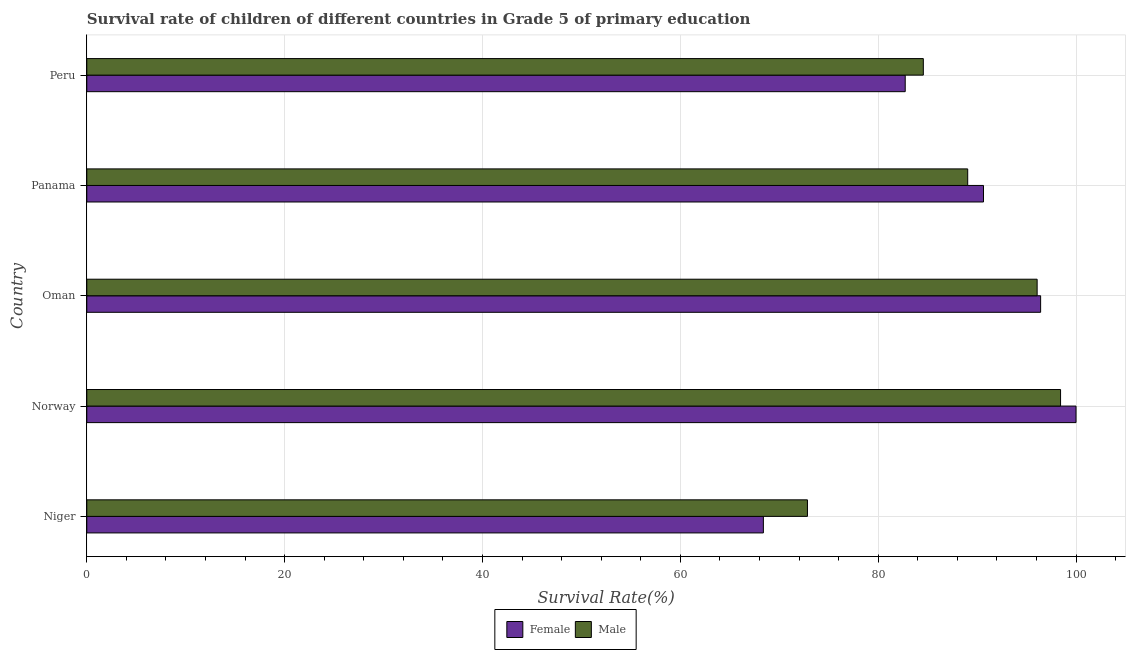How many different coloured bars are there?
Provide a succinct answer. 2. Are the number of bars on each tick of the Y-axis equal?
Offer a terse response. Yes. How many bars are there on the 4th tick from the bottom?
Offer a terse response. 2. What is the label of the 5th group of bars from the top?
Provide a short and direct response. Niger. What is the survival rate of female students in primary education in Oman?
Provide a short and direct response. 96.42. Across all countries, what is the maximum survival rate of male students in primary education?
Give a very brief answer. 98.44. Across all countries, what is the minimum survival rate of male students in primary education?
Offer a very short reply. 72.85. In which country was the survival rate of male students in primary education maximum?
Your answer should be compact. Norway. In which country was the survival rate of male students in primary education minimum?
Provide a succinct answer. Niger. What is the total survival rate of male students in primary education in the graph?
Offer a terse response. 440.97. What is the difference between the survival rate of female students in primary education in Niger and that in Peru?
Provide a short and direct response. -14.34. What is the difference between the survival rate of female students in primary education in Panama and the survival rate of male students in primary education in Peru?
Offer a terse response. 6.08. What is the average survival rate of female students in primary education per country?
Provide a short and direct response. 87.64. What is the difference between the survival rate of female students in primary education and survival rate of male students in primary education in Oman?
Provide a succinct answer. 0.35. In how many countries, is the survival rate of male students in primary education greater than 68 %?
Give a very brief answer. 5. What is the ratio of the survival rate of male students in primary education in Panama to that in Peru?
Keep it short and to the point. 1.05. Is the survival rate of female students in primary education in Norway less than that in Peru?
Your response must be concise. No. Is the difference between the survival rate of male students in primary education in Niger and Panama greater than the difference between the survival rate of female students in primary education in Niger and Panama?
Your answer should be compact. Yes. What is the difference between the highest and the second highest survival rate of male students in primary education?
Provide a succinct answer. 2.37. What is the difference between the highest and the lowest survival rate of male students in primary education?
Provide a short and direct response. 25.59. In how many countries, is the survival rate of male students in primary education greater than the average survival rate of male students in primary education taken over all countries?
Your answer should be compact. 3. Are all the bars in the graph horizontal?
Make the answer very short. Yes. How many countries are there in the graph?
Give a very brief answer. 5. Does the graph contain any zero values?
Provide a short and direct response. No. Does the graph contain grids?
Offer a very short reply. Yes. How many legend labels are there?
Your answer should be very brief. 2. How are the legend labels stacked?
Offer a very short reply. Horizontal. What is the title of the graph?
Keep it short and to the point. Survival rate of children of different countries in Grade 5 of primary education. Does "National Visitors" appear as one of the legend labels in the graph?
Give a very brief answer. No. What is the label or title of the X-axis?
Offer a terse response. Survival Rate(%). What is the Survival Rate(%) of Female in Niger?
Provide a short and direct response. 68.39. What is the Survival Rate(%) of Male in Niger?
Your answer should be very brief. 72.85. What is the Survival Rate(%) of Female in Norway?
Give a very brief answer. 100. What is the Survival Rate(%) in Male in Norway?
Provide a succinct answer. 98.44. What is the Survival Rate(%) of Female in Oman?
Ensure brevity in your answer.  96.42. What is the Survival Rate(%) in Male in Oman?
Ensure brevity in your answer.  96.07. What is the Survival Rate(%) in Female in Panama?
Offer a terse response. 90.65. What is the Survival Rate(%) of Male in Panama?
Give a very brief answer. 89.05. What is the Survival Rate(%) of Female in Peru?
Provide a short and direct response. 82.73. What is the Survival Rate(%) of Male in Peru?
Provide a short and direct response. 84.56. Across all countries, what is the maximum Survival Rate(%) in Male?
Your answer should be compact. 98.44. Across all countries, what is the minimum Survival Rate(%) of Female?
Your answer should be very brief. 68.39. Across all countries, what is the minimum Survival Rate(%) of Male?
Your answer should be compact. 72.85. What is the total Survival Rate(%) in Female in the graph?
Make the answer very short. 438.2. What is the total Survival Rate(%) in Male in the graph?
Offer a very short reply. 440.97. What is the difference between the Survival Rate(%) in Female in Niger and that in Norway?
Give a very brief answer. -31.61. What is the difference between the Survival Rate(%) of Male in Niger and that in Norway?
Offer a terse response. -25.59. What is the difference between the Survival Rate(%) in Female in Niger and that in Oman?
Give a very brief answer. -28.03. What is the difference between the Survival Rate(%) in Male in Niger and that in Oman?
Give a very brief answer. -23.22. What is the difference between the Survival Rate(%) in Female in Niger and that in Panama?
Keep it short and to the point. -22.25. What is the difference between the Survival Rate(%) of Male in Niger and that in Panama?
Your answer should be very brief. -16.2. What is the difference between the Survival Rate(%) of Female in Niger and that in Peru?
Keep it short and to the point. -14.34. What is the difference between the Survival Rate(%) of Male in Niger and that in Peru?
Your answer should be very brief. -11.71. What is the difference between the Survival Rate(%) in Female in Norway and that in Oman?
Keep it short and to the point. 3.58. What is the difference between the Survival Rate(%) in Male in Norway and that in Oman?
Ensure brevity in your answer.  2.37. What is the difference between the Survival Rate(%) in Female in Norway and that in Panama?
Offer a very short reply. 9.35. What is the difference between the Survival Rate(%) of Male in Norway and that in Panama?
Give a very brief answer. 9.39. What is the difference between the Survival Rate(%) of Female in Norway and that in Peru?
Provide a short and direct response. 17.27. What is the difference between the Survival Rate(%) of Male in Norway and that in Peru?
Give a very brief answer. 13.87. What is the difference between the Survival Rate(%) in Female in Oman and that in Panama?
Give a very brief answer. 5.78. What is the difference between the Survival Rate(%) in Male in Oman and that in Panama?
Your response must be concise. 7.02. What is the difference between the Survival Rate(%) in Female in Oman and that in Peru?
Give a very brief answer. 13.69. What is the difference between the Survival Rate(%) of Male in Oman and that in Peru?
Offer a terse response. 11.5. What is the difference between the Survival Rate(%) of Female in Panama and that in Peru?
Your answer should be very brief. 7.91. What is the difference between the Survival Rate(%) in Male in Panama and that in Peru?
Give a very brief answer. 4.49. What is the difference between the Survival Rate(%) of Female in Niger and the Survival Rate(%) of Male in Norway?
Offer a terse response. -30.04. What is the difference between the Survival Rate(%) in Female in Niger and the Survival Rate(%) in Male in Oman?
Your answer should be compact. -27.67. What is the difference between the Survival Rate(%) in Female in Niger and the Survival Rate(%) in Male in Panama?
Offer a very short reply. -20.66. What is the difference between the Survival Rate(%) in Female in Niger and the Survival Rate(%) in Male in Peru?
Offer a terse response. -16.17. What is the difference between the Survival Rate(%) of Female in Norway and the Survival Rate(%) of Male in Oman?
Your response must be concise. 3.93. What is the difference between the Survival Rate(%) of Female in Norway and the Survival Rate(%) of Male in Panama?
Your answer should be compact. 10.95. What is the difference between the Survival Rate(%) in Female in Norway and the Survival Rate(%) in Male in Peru?
Your response must be concise. 15.44. What is the difference between the Survival Rate(%) of Female in Oman and the Survival Rate(%) of Male in Panama?
Provide a short and direct response. 7.37. What is the difference between the Survival Rate(%) of Female in Oman and the Survival Rate(%) of Male in Peru?
Your answer should be very brief. 11.86. What is the difference between the Survival Rate(%) of Female in Panama and the Survival Rate(%) of Male in Peru?
Provide a succinct answer. 6.08. What is the average Survival Rate(%) in Female per country?
Your answer should be very brief. 87.64. What is the average Survival Rate(%) in Male per country?
Provide a short and direct response. 88.19. What is the difference between the Survival Rate(%) of Female and Survival Rate(%) of Male in Niger?
Give a very brief answer. -4.46. What is the difference between the Survival Rate(%) in Female and Survival Rate(%) in Male in Norway?
Your response must be concise. 1.56. What is the difference between the Survival Rate(%) in Female and Survival Rate(%) in Male in Oman?
Give a very brief answer. 0.35. What is the difference between the Survival Rate(%) of Female and Survival Rate(%) of Male in Panama?
Make the answer very short. 1.6. What is the difference between the Survival Rate(%) of Female and Survival Rate(%) of Male in Peru?
Keep it short and to the point. -1.83. What is the ratio of the Survival Rate(%) in Female in Niger to that in Norway?
Offer a very short reply. 0.68. What is the ratio of the Survival Rate(%) of Male in Niger to that in Norway?
Your response must be concise. 0.74. What is the ratio of the Survival Rate(%) in Female in Niger to that in Oman?
Give a very brief answer. 0.71. What is the ratio of the Survival Rate(%) in Male in Niger to that in Oman?
Keep it short and to the point. 0.76. What is the ratio of the Survival Rate(%) in Female in Niger to that in Panama?
Keep it short and to the point. 0.75. What is the ratio of the Survival Rate(%) of Male in Niger to that in Panama?
Your answer should be compact. 0.82. What is the ratio of the Survival Rate(%) in Female in Niger to that in Peru?
Your response must be concise. 0.83. What is the ratio of the Survival Rate(%) of Male in Niger to that in Peru?
Provide a short and direct response. 0.86. What is the ratio of the Survival Rate(%) of Female in Norway to that in Oman?
Your response must be concise. 1.04. What is the ratio of the Survival Rate(%) of Male in Norway to that in Oman?
Give a very brief answer. 1.02. What is the ratio of the Survival Rate(%) of Female in Norway to that in Panama?
Your answer should be compact. 1.1. What is the ratio of the Survival Rate(%) of Male in Norway to that in Panama?
Your response must be concise. 1.11. What is the ratio of the Survival Rate(%) in Female in Norway to that in Peru?
Give a very brief answer. 1.21. What is the ratio of the Survival Rate(%) in Male in Norway to that in Peru?
Keep it short and to the point. 1.16. What is the ratio of the Survival Rate(%) in Female in Oman to that in Panama?
Ensure brevity in your answer.  1.06. What is the ratio of the Survival Rate(%) in Male in Oman to that in Panama?
Give a very brief answer. 1.08. What is the ratio of the Survival Rate(%) of Female in Oman to that in Peru?
Ensure brevity in your answer.  1.17. What is the ratio of the Survival Rate(%) of Male in Oman to that in Peru?
Ensure brevity in your answer.  1.14. What is the ratio of the Survival Rate(%) of Female in Panama to that in Peru?
Ensure brevity in your answer.  1.1. What is the ratio of the Survival Rate(%) of Male in Panama to that in Peru?
Keep it short and to the point. 1.05. What is the difference between the highest and the second highest Survival Rate(%) in Female?
Ensure brevity in your answer.  3.58. What is the difference between the highest and the second highest Survival Rate(%) of Male?
Keep it short and to the point. 2.37. What is the difference between the highest and the lowest Survival Rate(%) of Female?
Offer a terse response. 31.61. What is the difference between the highest and the lowest Survival Rate(%) of Male?
Your answer should be very brief. 25.59. 